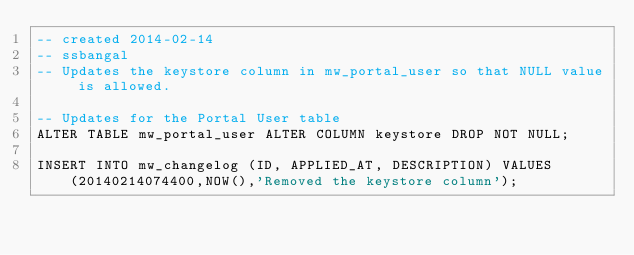<code> <loc_0><loc_0><loc_500><loc_500><_SQL_>-- created 2014-02-14
-- ssbangal
-- Updates the keystore column in mw_portal_user so that NULL value is allowed.

-- Updates for the Portal User table
ALTER TABLE mw_portal_user ALTER COLUMN keystore DROP NOT NULL;

INSERT INTO mw_changelog (ID, APPLIED_AT, DESCRIPTION) VALUES (20140214074400,NOW(),'Removed the keystore column');
</code> 